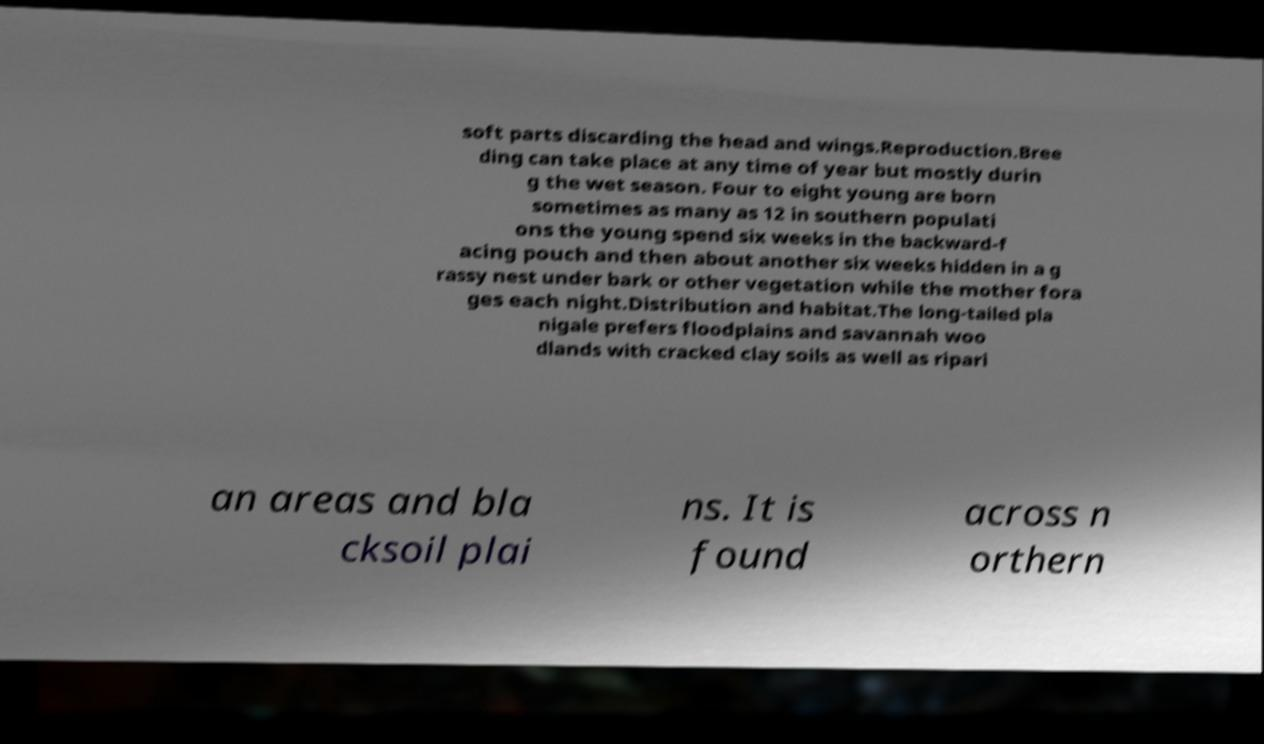There's text embedded in this image that I need extracted. Can you transcribe it verbatim? soft parts discarding the head and wings.Reproduction.Bree ding can take place at any time of year but mostly durin g the wet season. Four to eight young are born sometimes as many as 12 in southern populati ons the young spend six weeks in the backward-f acing pouch and then about another six weeks hidden in a g rassy nest under bark or other vegetation while the mother fora ges each night.Distribution and habitat.The long-tailed pla nigale prefers floodplains and savannah woo dlands with cracked clay soils as well as ripari an areas and bla cksoil plai ns. It is found across n orthern 